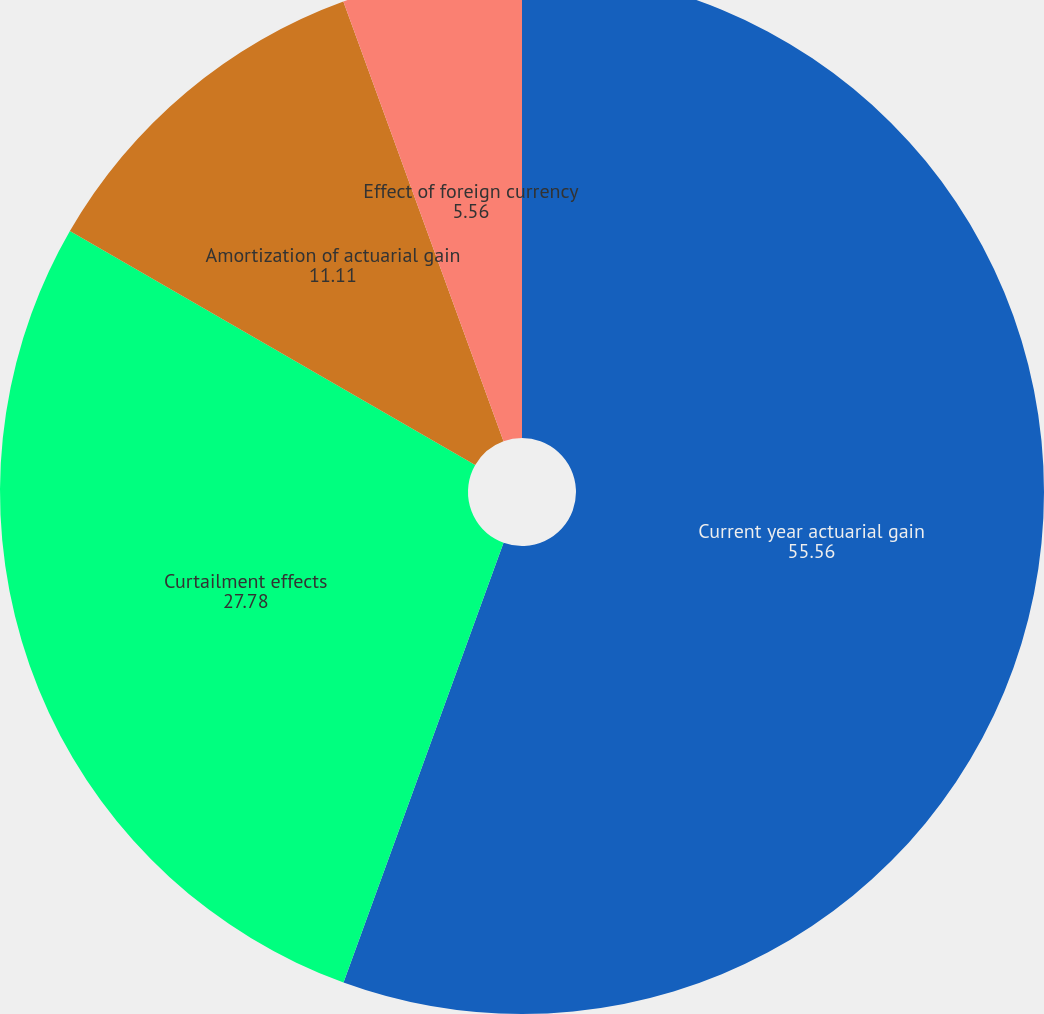Convert chart. <chart><loc_0><loc_0><loc_500><loc_500><pie_chart><fcel>Current year actuarial gain<fcel>Curtailment effects<fcel>Amortization of actuarial gain<fcel>Effect of foreign currency<nl><fcel>55.56%<fcel>27.78%<fcel>11.11%<fcel>5.56%<nl></chart> 